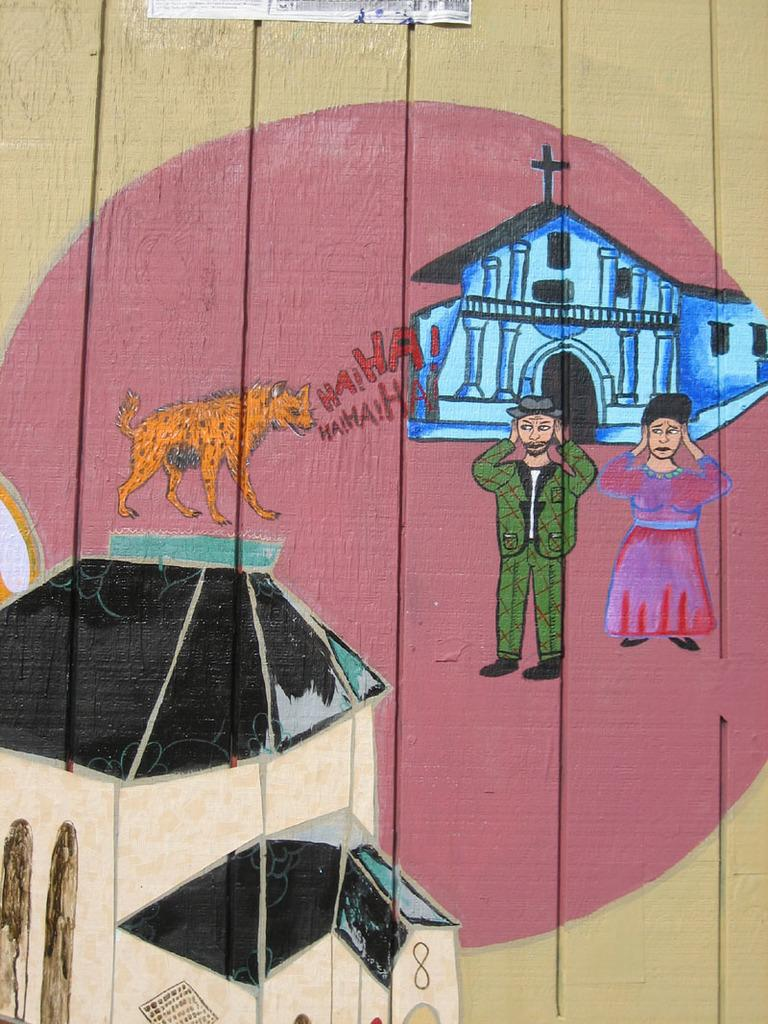What is the main subject of the image? The main subject of the image is a painting. What can be seen in the painting? The painting contains persons, a building, and an animal. What type of oatmeal is being served in the painting? There is no oatmeal present in the painting; it contains persons, a building, and an animal. What type of pleasure can be seen on the faces of the persons in the painting? The provided facts do not mention any expressions or emotions on the faces of the persons in the painting, so we cannot determine their pleasure. 